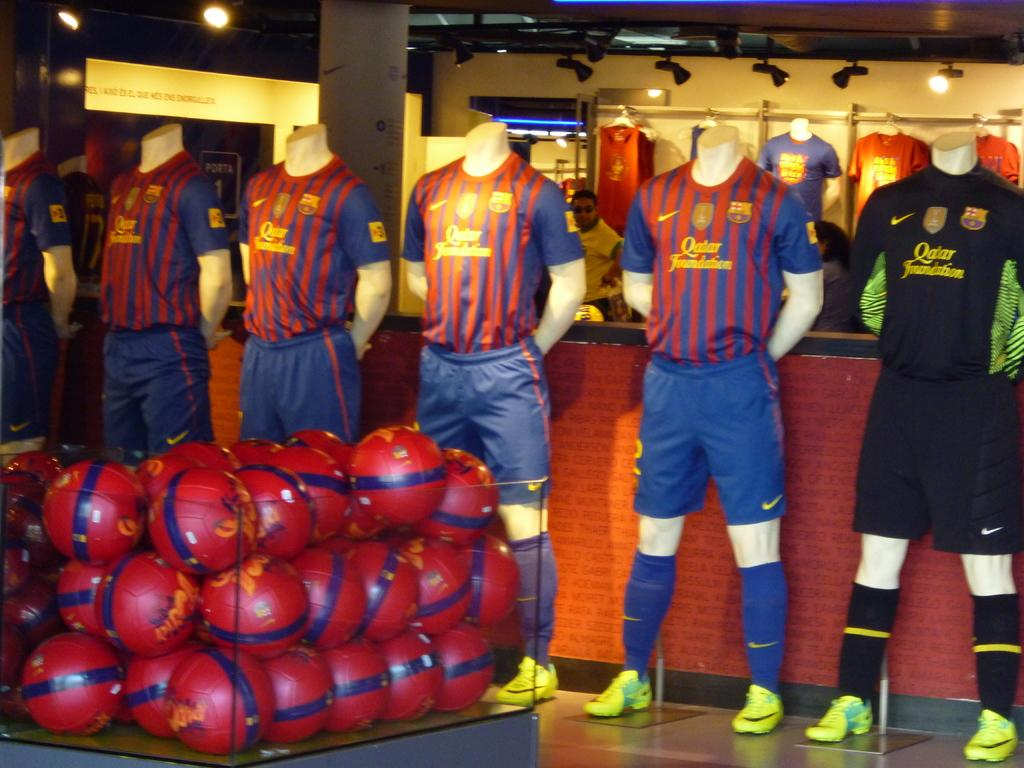<image>
Summarize the visual content of the image. some Qatar sports clothing and balls displayed. 